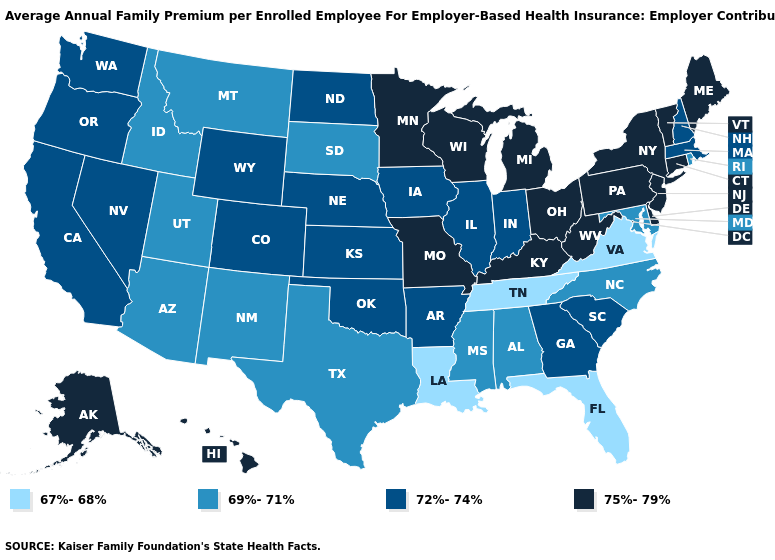Which states have the lowest value in the MidWest?
Short answer required. South Dakota. Which states have the lowest value in the USA?
Give a very brief answer. Florida, Louisiana, Tennessee, Virginia. Is the legend a continuous bar?
Answer briefly. No. Is the legend a continuous bar?
Short answer required. No. What is the value of South Dakota?
Short answer required. 69%-71%. What is the value of Colorado?
Be succinct. 72%-74%. Is the legend a continuous bar?
Write a very short answer. No. Does Connecticut have the highest value in the USA?
Write a very short answer. Yes. Does Connecticut have the lowest value in the USA?
Keep it brief. No. What is the value of Georgia?
Give a very brief answer. 72%-74%. Name the states that have a value in the range 75%-79%?
Answer briefly. Alaska, Connecticut, Delaware, Hawaii, Kentucky, Maine, Michigan, Minnesota, Missouri, New Jersey, New York, Ohio, Pennsylvania, Vermont, West Virginia, Wisconsin. Does the map have missing data?
Short answer required. No. Does Rhode Island have a higher value than Maryland?
Concise answer only. No. Name the states that have a value in the range 67%-68%?
Quick response, please. Florida, Louisiana, Tennessee, Virginia. Does Louisiana have the lowest value in the USA?
Be succinct. Yes. 